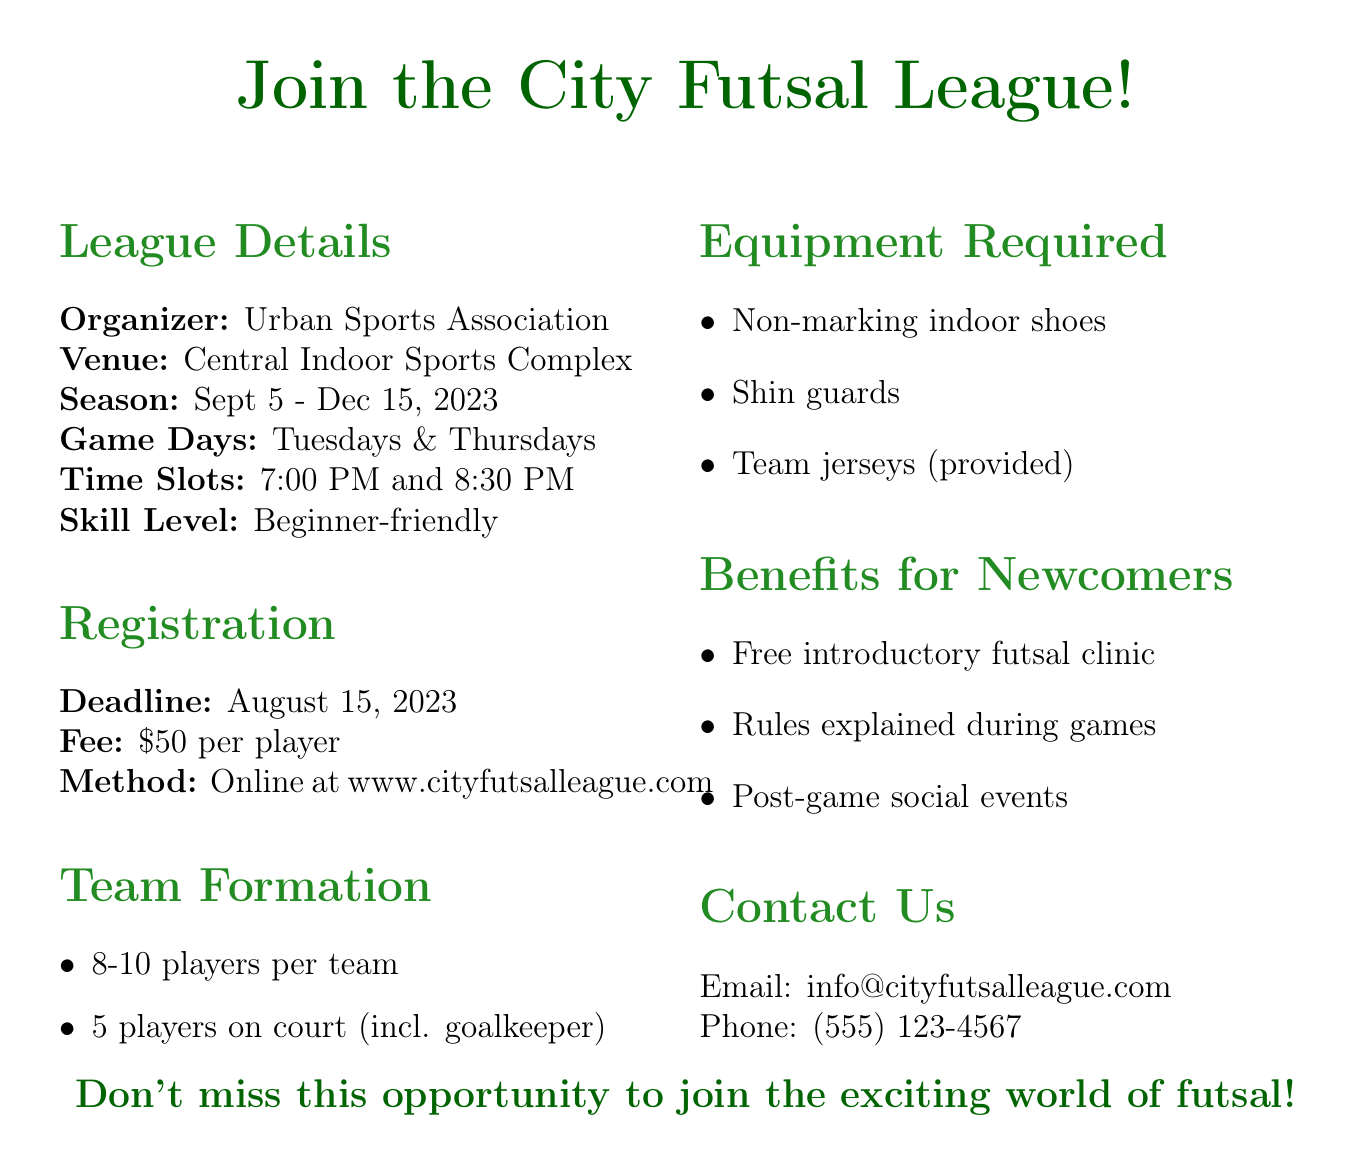What is the name of the league? The league is called "City Futsal League."
Answer: City Futsal League Who is the organizer of the league? The organizer of the league is the Urban Sports Association.
Answer: Urban Sports Association When is the registration deadline? The registration deadline is stated in the document as August 15, 2023.
Answer: August 15, 2023 How much is the registration fee per player? The document specifies that the fee is $50 per player.
Answer: $50 per player On what days are the games scheduled? The games are scheduled for Tuesday and Thursday evenings.
Answer: Tuesday and Thursday What are the required equipment items? The required equipment includes non-marking indoor shoes, shin guards, and team jerseys.
Answer: Non-marking indoor shoes, shin guards, team jerseys How many players are typically on a team? The document states that there are usually 8-10 players per team.
Answer: 8-10 What benefits do newcomers receive? Newcomers receive a free introductory futsal clinic, rules explained during games, and post-game social events.
Answer: Free introductory futsal clinic, rules explained, post-game social events What is the venue for the league? The venue for the league is the Central Indoor Sports Complex.
Answer: Central Indoor Sports Complex 